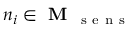Convert formula to latex. <formula><loc_0><loc_0><loc_500><loc_500>n _ { i } \in M _ { s e n s }</formula> 